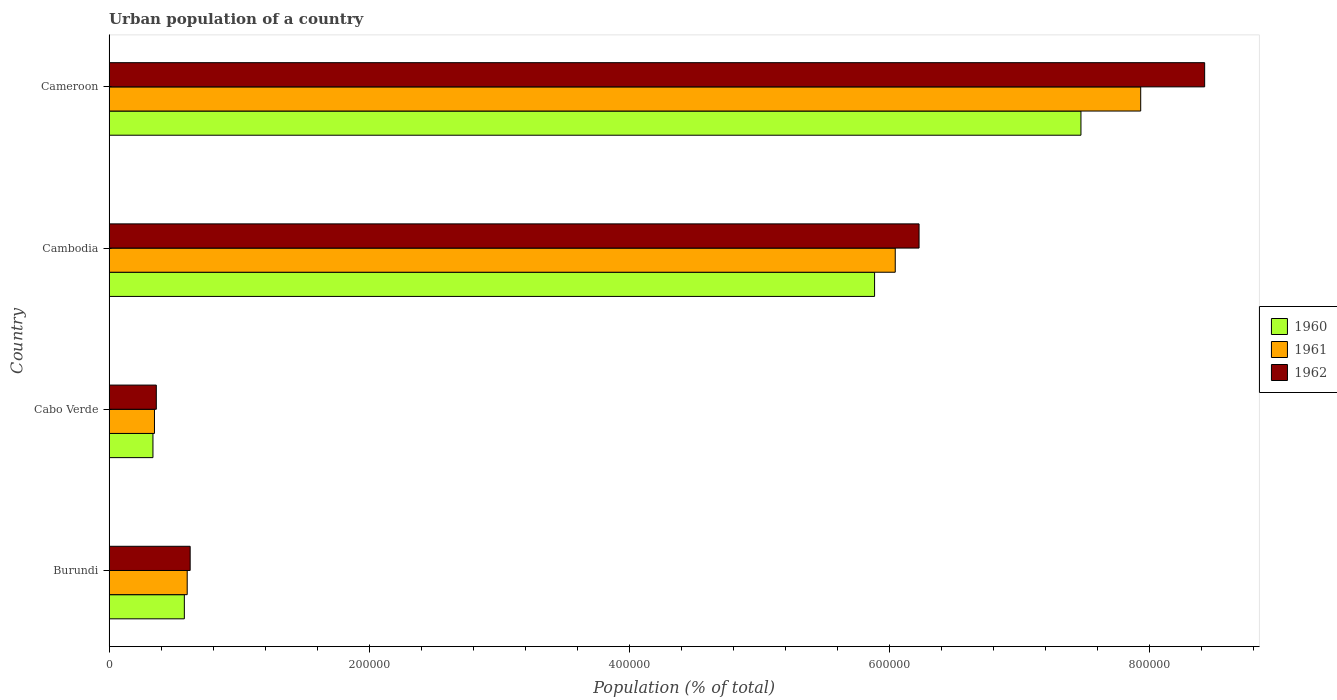How many groups of bars are there?
Offer a terse response. 4. Are the number of bars on each tick of the Y-axis equal?
Provide a succinct answer. Yes. How many bars are there on the 2nd tick from the bottom?
Provide a succinct answer. 3. What is the label of the 3rd group of bars from the top?
Provide a succinct answer. Cabo Verde. What is the urban population in 1960 in Burundi?
Make the answer very short. 5.79e+04. Across all countries, what is the maximum urban population in 1961?
Offer a terse response. 7.93e+05. Across all countries, what is the minimum urban population in 1962?
Your response must be concise. 3.63e+04. In which country was the urban population in 1961 maximum?
Provide a short and direct response. Cameroon. In which country was the urban population in 1961 minimum?
Keep it short and to the point. Cabo Verde. What is the total urban population in 1961 in the graph?
Your answer should be very brief. 1.49e+06. What is the difference between the urban population in 1961 in Cambodia and that in Cameroon?
Ensure brevity in your answer.  -1.89e+05. What is the difference between the urban population in 1960 in Cameroon and the urban population in 1962 in Cambodia?
Provide a short and direct response. 1.24e+05. What is the average urban population in 1961 per country?
Give a very brief answer. 3.73e+05. What is the difference between the urban population in 1962 and urban population in 1960 in Cambodia?
Give a very brief answer. 3.42e+04. In how many countries, is the urban population in 1961 greater than 840000 %?
Make the answer very short. 0. What is the ratio of the urban population in 1960 in Burundi to that in Cabo Verde?
Provide a short and direct response. 1.72. What is the difference between the highest and the second highest urban population in 1961?
Your response must be concise. 1.89e+05. What is the difference between the highest and the lowest urban population in 1961?
Your answer should be compact. 7.58e+05. In how many countries, is the urban population in 1961 greater than the average urban population in 1961 taken over all countries?
Give a very brief answer. 2. Is the sum of the urban population in 1961 in Cabo Verde and Cameroon greater than the maximum urban population in 1962 across all countries?
Make the answer very short. No. What does the 3rd bar from the top in Cameroon represents?
Give a very brief answer. 1960. What does the 1st bar from the bottom in Cameroon represents?
Your answer should be compact. 1960. How many bars are there?
Your answer should be very brief. 12. Are all the bars in the graph horizontal?
Your answer should be very brief. Yes. How many countries are there in the graph?
Keep it short and to the point. 4. What is the difference between two consecutive major ticks on the X-axis?
Offer a very short reply. 2.00e+05. Are the values on the major ticks of X-axis written in scientific E-notation?
Your answer should be compact. No. Does the graph contain any zero values?
Your answer should be compact. No. Does the graph contain grids?
Your response must be concise. No. What is the title of the graph?
Provide a succinct answer. Urban population of a country. Does "1962" appear as one of the legend labels in the graph?
Provide a succinct answer. Yes. What is the label or title of the X-axis?
Ensure brevity in your answer.  Population (% of total). What is the Population (% of total) of 1960 in Burundi?
Your answer should be compact. 5.79e+04. What is the Population (% of total) of 1961 in Burundi?
Make the answer very short. 6.01e+04. What is the Population (% of total) in 1962 in Burundi?
Make the answer very short. 6.23e+04. What is the Population (% of total) in 1960 in Cabo Verde?
Keep it short and to the point. 3.37e+04. What is the Population (% of total) in 1961 in Cabo Verde?
Make the answer very short. 3.49e+04. What is the Population (% of total) in 1962 in Cabo Verde?
Provide a succinct answer. 3.63e+04. What is the Population (% of total) in 1960 in Cambodia?
Your answer should be compact. 5.89e+05. What is the Population (% of total) of 1961 in Cambodia?
Your answer should be very brief. 6.04e+05. What is the Population (% of total) in 1962 in Cambodia?
Offer a terse response. 6.23e+05. What is the Population (% of total) of 1960 in Cameroon?
Provide a short and direct response. 7.47e+05. What is the Population (% of total) in 1961 in Cameroon?
Provide a succinct answer. 7.93e+05. What is the Population (% of total) in 1962 in Cameroon?
Your response must be concise. 8.42e+05. Across all countries, what is the maximum Population (% of total) in 1960?
Provide a succinct answer. 7.47e+05. Across all countries, what is the maximum Population (% of total) of 1961?
Provide a succinct answer. 7.93e+05. Across all countries, what is the maximum Population (% of total) in 1962?
Your answer should be compact. 8.42e+05. Across all countries, what is the minimum Population (% of total) in 1960?
Give a very brief answer. 3.37e+04. Across all countries, what is the minimum Population (% of total) in 1961?
Keep it short and to the point. 3.49e+04. Across all countries, what is the minimum Population (% of total) in 1962?
Give a very brief answer. 3.63e+04. What is the total Population (% of total) in 1960 in the graph?
Make the answer very short. 1.43e+06. What is the total Population (% of total) in 1961 in the graph?
Your answer should be very brief. 1.49e+06. What is the total Population (% of total) of 1962 in the graph?
Your answer should be very brief. 1.56e+06. What is the difference between the Population (% of total) of 1960 in Burundi and that in Cabo Verde?
Make the answer very short. 2.41e+04. What is the difference between the Population (% of total) in 1961 in Burundi and that in Cabo Verde?
Provide a succinct answer. 2.52e+04. What is the difference between the Population (% of total) in 1962 in Burundi and that in Cabo Verde?
Provide a short and direct response. 2.60e+04. What is the difference between the Population (% of total) in 1960 in Burundi and that in Cambodia?
Your response must be concise. -5.31e+05. What is the difference between the Population (% of total) in 1961 in Burundi and that in Cambodia?
Offer a terse response. -5.44e+05. What is the difference between the Population (% of total) of 1962 in Burundi and that in Cambodia?
Make the answer very short. -5.60e+05. What is the difference between the Population (% of total) in 1960 in Burundi and that in Cameroon?
Offer a very short reply. -6.89e+05. What is the difference between the Population (% of total) in 1961 in Burundi and that in Cameroon?
Give a very brief answer. -7.33e+05. What is the difference between the Population (% of total) in 1962 in Burundi and that in Cameroon?
Give a very brief answer. -7.80e+05. What is the difference between the Population (% of total) of 1960 in Cabo Verde and that in Cambodia?
Provide a short and direct response. -5.55e+05. What is the difference between the Population (% of total) in 1961 in Cabo Verde and that in Cambodia?
Provide a succinct answer. -5.70e+05. What is the difference between the Population (% of total) of 1962 in Cabo Verde and that in Cambodia?
Give a very brief answer. -5.86e+05. What is the difference between the Population (% of total) in 1960 in Cabo Verde and that in Cameroon?
Give a very brief answer. -7.13e+05. What is the difference between the Population (% of total) in 1961 in Cabo Verde and that in Cameroon?
Provide a short and direct response. -7.58e+05. What is the difference between the Population (% of total) in 1962 in Cabo Verde and that in Cameroon?
Give a very brief answer. -8.06e+05. What is the difference between the Population (% of total) in 1960 in Cambodia and that in Cameroon?
Your answer should be very brief. -1.59e+05. What is the difference between the Population (% of total) in 1961 in Cambodia and that in Cameroon?
Provide a succinct answer. -1.89e+05. What is the difference between the Population (% of total) of 1962 in Cambodia and that in Cameroon?
Your answer should be very brief. -2.20e+05. What is the difference between the Population (% of total) of 1960 in Burundi and the Population (% of total) of 1961 in Cabo Verde?
Your answer should be compact. 2.30e+04. What is the difference between the Population (% of total) of 1960 in Burundi and the Population (% of total) of 1962 in Cabo Verde?
Provide a short and direct response. 2.16e+04. What is the difference between the Population (% of total) in 1961 in Burundi and the Population (% of total) in 1962 in Cabo Verde?
Ensure brevity in your answer.  2.38e+04. What is the difference between the Population (% of total) of 1960 in Burundi and the Population (% of total) of 1961 in Cambodia?
Make the answer very short. -5.47e+05. What is the difference between the Population (% of total) in 1960 in Burundi and the Population (% of total) in 1962 in Cambodia?
Make the answer very short. -5.65e+05. What is the difference between the Population (% of total) in 1961 in Burundi and the Population (% of total) in 1962 in Cambodia?
Your response must be concise. -5.63e+05. What is the difference between the Population (% of total) of 1960 in Burundi and the Population (% of total) of 1961 in Cameroon?
Offer a very short reply. -7.35e+05. What is the difference between the Population (% of total) in 1960 in Burundi and the Population (% of total) in 1962 in Cameroon?
Give a very brief answer. -7.84e+05. What is the difference between the Population (% of total) in 1961 in Burundi and the Population (% of total) in 1962 in Cameroon?
Keep it short and to the point. -7.82e+05. What is the difference between the Population (% of total) of 1960 in Cabo Verde and the Population (% of total) of 1961 in Cambodia?
Offer a very short reply. -5.71e+05. What is the difference between the Population (% of total) in 1960 in Cabo Verde and the Population (% of total) in 1962 in Cambodia?
Give a very brief answer. -5.89e+05. What is the difference between the Population (% of total) of 1961 in Cabo Verde and the Population (% of total) of 1962 in Cambodia?
Your answer should be compact. -5.88e+05. What is the difference between the Population (% of total) of 1960 in Cabo Verde and the Population (% of total) of 1961 in Cameroon?
Your answer should be compact. -7.59e+05. What is the difference between the Population (% of total) in 1960 in Cabo Verde and the Population (% of total) in 1962 in Cameroon?
Provide a succinct answer. -8.09e+05. What is the difference between the Population (% of total) of 1961 in Cabo Verde and the Population (% of total) of 1962 in Cameroon?
Provide a short and direct response. -8.07e+05. What is the difference between the Population (% of total) in 1960 in Cambodia and the Population (% of total) in 1961 in Cameroon?
Give a very brief answer. -2.05e+05. What is the difference between the Population (% of total) of 1960 in Cambodia and the Population (% of total) of 1962 in Cameroon?
Provide a short and direct response. -2.54e+05. What is the difference between the Population (% of total) of 1961 in Cambodia and the Population (% of total) of 1962 in Cameroon?
Your answer should be compact. -2.38e+05. What is the average Population (% of total) of 1960 per country?
Offer a terse response. 3.57e+05. What is the average Population (% of total) in 1961 per country?
Keep it short and to the point. 3.73e+05. What is the average Population (% of total) of 1962 per country?
Provide a short and direct response. 3.91e+05. What is the difference between the Population (% of total) of 1960 and Population (% of total) of 1961 in Burundi?
Your answer should be compact. -2193. What is the difference between the Population (% of total) in 1960 and Population (% of total) in 1962 in Burundi?
Give a very brief answer. -4467. What is the difference between the Population (% of total) in 1961 and Population (% of total) in 1962 in Burundi?
Provide a succinct answer. -2274. What is the difference between the Population (% of total) of 1960 and Population (% of total) of 1961 in Cabo Verde?
Your answer should be very brief. -1162. What is the difference between the Population (% of total) in 1960 and Population (% of total) in 1962 in Cabo Verde?
Give a very brief answer. -2576. What is the difference between the Population (% of total) in 1961 and Population (% of total) in 1962 in Cabo Verde?
Make the answer very short. -1414. What is the difference between the Population (% of total) in 1960 and Population (% of total) in 1961 in Cambodia?
Provide a short and direct response. -1.59e+04. What is the difference between the Population (% of total) in 1960 and Population (% of total) in 1962 in Cambodia?
Your answer should be very brief. -3.42e+04. What is the difference between the Population (% of total) of 1961 and Population (% of total) of 1962 in Cambodia?
Your answer should be very brief. -1.83e+04. What is the difference between the Population (% of total) of 1960 and Population (% of total) of 1961 in Cameroon?
Offer a terse response. -4.59e+04. What is the difference between the Population (% of total) of 1960 and Population (% of total) of 1962 in Cameroon?
Provide a succinct answer. -9.51e+04. What is the difference between the Population (% of total) of 1961 and Population (% of total) of 1962 in Cameroon?
Keep it short and to the point. -4.92e+04. What is the ratio of the Population (% of total) of 1960 in Burundi to that in Cabo Verde?
Provide a short and direct response. 1.72. What is the ratio of the Population (% of total) of 1961 in Burundi to that in Cabo Verde?
Your answer should be very brief. 1.72. What is the ratio of the Population (% of total) in 1962 in Burundi to that in Cabo Verde?
Provide a succinct answer. 1.72. What is the ratio of the Population (% of total) in 1960 in Burundi to that in Cambodia?
Provide a succinct answer. 0.1. What is the ratio of the Population (% of total) in 1961 in Burundi to that in Cambodia?
Provide a short and direct response. 0.1. What is the ratio of the Population (% of total) in 1962 in Burundi to that in Cambodia?
Ensure brevity in your answer.  0.1. What is the ratio of the Population (% of total) in 1960 in Burundi to that in Cameroon?
Ensure brevity in your answer.  0.08. What is the ratio of the Population (% of total) in 1961 in Burundi to that in Cameroon?
Your response must be concise. 0.08. What is the ratio of the Population (% of total) of 1962 in Burundi to that in Cameroon?
Your answer should be very brief. 0.07. What is the ratio of the Population (% of total) of 1960 in Cabo Verde to that in Cambodia?
Make the answer very short. 0.06. What is the ratio of the Population (% of total) of 1961 in Cabo Verde to that in Cambodia?
Keep it short and to the point. 0.06. What is the ratio of the Population (% of total) of 1962 in Cabo Verde to that in Cambodia?
Ensure brevity in your answer.  0.06. What is the ratio of the Population (% of total) of 1960 in Cabo Verde to that in Cameroon?
Keep it short and to the point. 0.05. What is the ratio of the Population (% of total) of 1961 in Cabo Verde to that in Cameroon?
Ensure brevity in your answer.  0.04. What is the ratio of the Population (% of total) in 1962 in Cabo Verde to that in Cameroon?
Provide a succinct answer. 0.04. What is the ratio of the Population (% of total) in 1960 in Cambodia to that in Cameroon?
Offer a terse response. 0.79. What is the ratio of the Population (% of total) of 1961 in Cambodia to that in Cameroon?
Provide a short and direct response. 0.76. What is the ratio of the Population (% of total) in 1962 in Cambodia to that in Cameroon?
Make the answer very short. 0.74. What is the difference between the highest and the second highest Population (% of total) of 1960?
Provide a short and direct response. 1.59e+05. What is the difference between the highest and the second highest Population (% of total) in 1961?
Your response must be concise. 1.89e+05. What is the difference between the highest and the second highest Population (% of total) in 1962?
Keep it short and to the point. 2.20e+05. What is the difference between the highest and the lowest Population (% of total) of 1960?
Offer a very short reply. 7.13e+05. What is the difference between the highest and the lowest Population (% of total) of 1961?
Give a very brief answer. 7.58e+05. What is the difference between the highest and the lowest Population (% of total) in 1962?
Provide a short and direct response. 8.06e+05. 